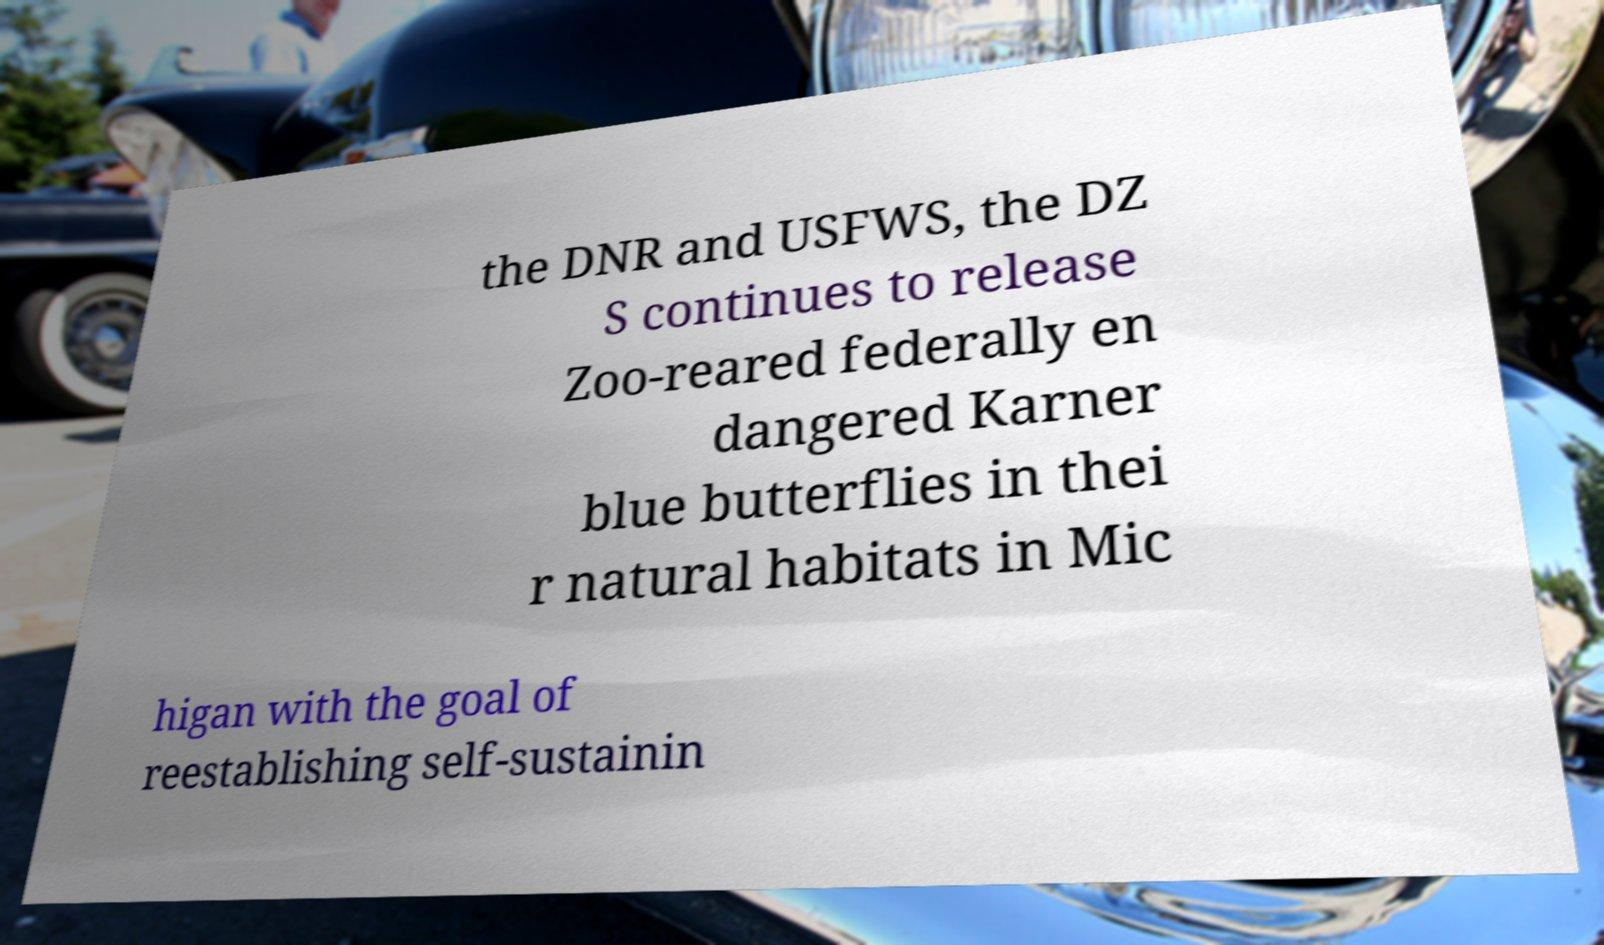Can you read and provide the text displayed in the image?This photo seems to have some interesting text. Can you extract and type it out for me? the DNR and USFWS, the DZ S continues to release Zoo-reared federally en dangered Karner blue butterflies in thei r natural habitats in Mic higan with the goal of reestablishing self-sustainin 